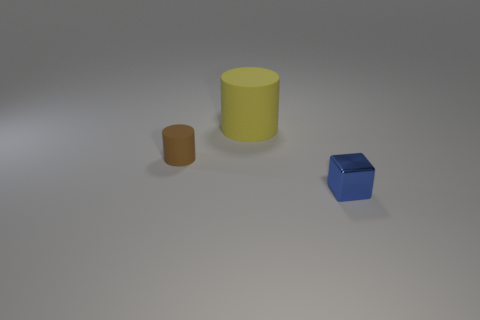Is there anything else that is the same shape as the big thing? Yes, the smaller brown object is a cylinder, much like the larger yellow one, but it's smaller in size. 